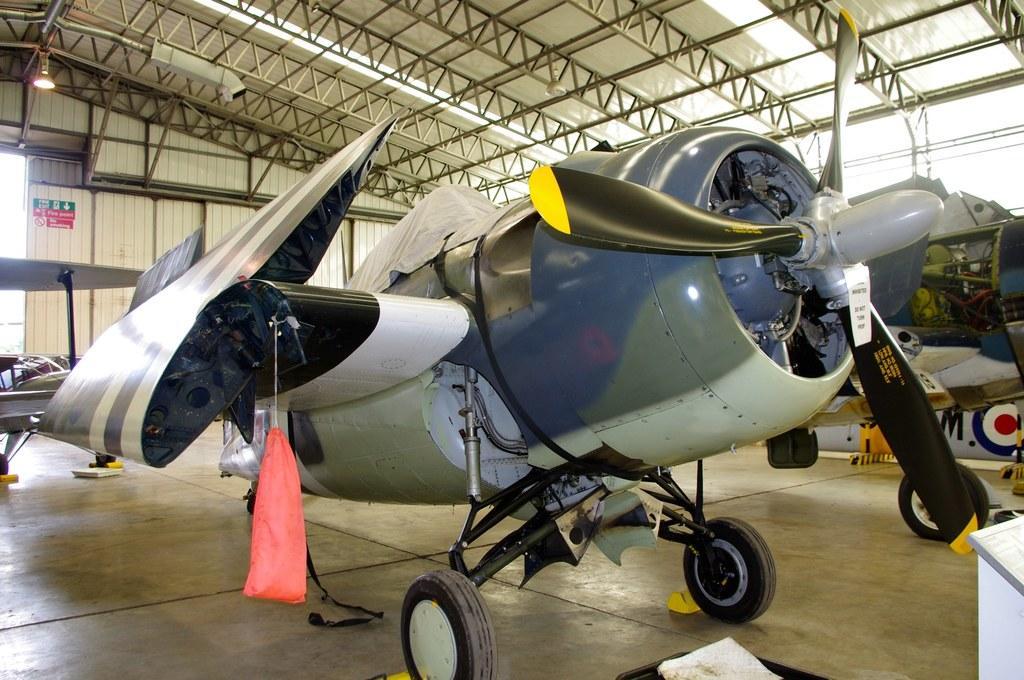Describe this image in one or two sentences. In this picture there is an aeroplane in the center of the image and there is a roof at the top side of the image, there is another aeroplane on the right side of the image. 